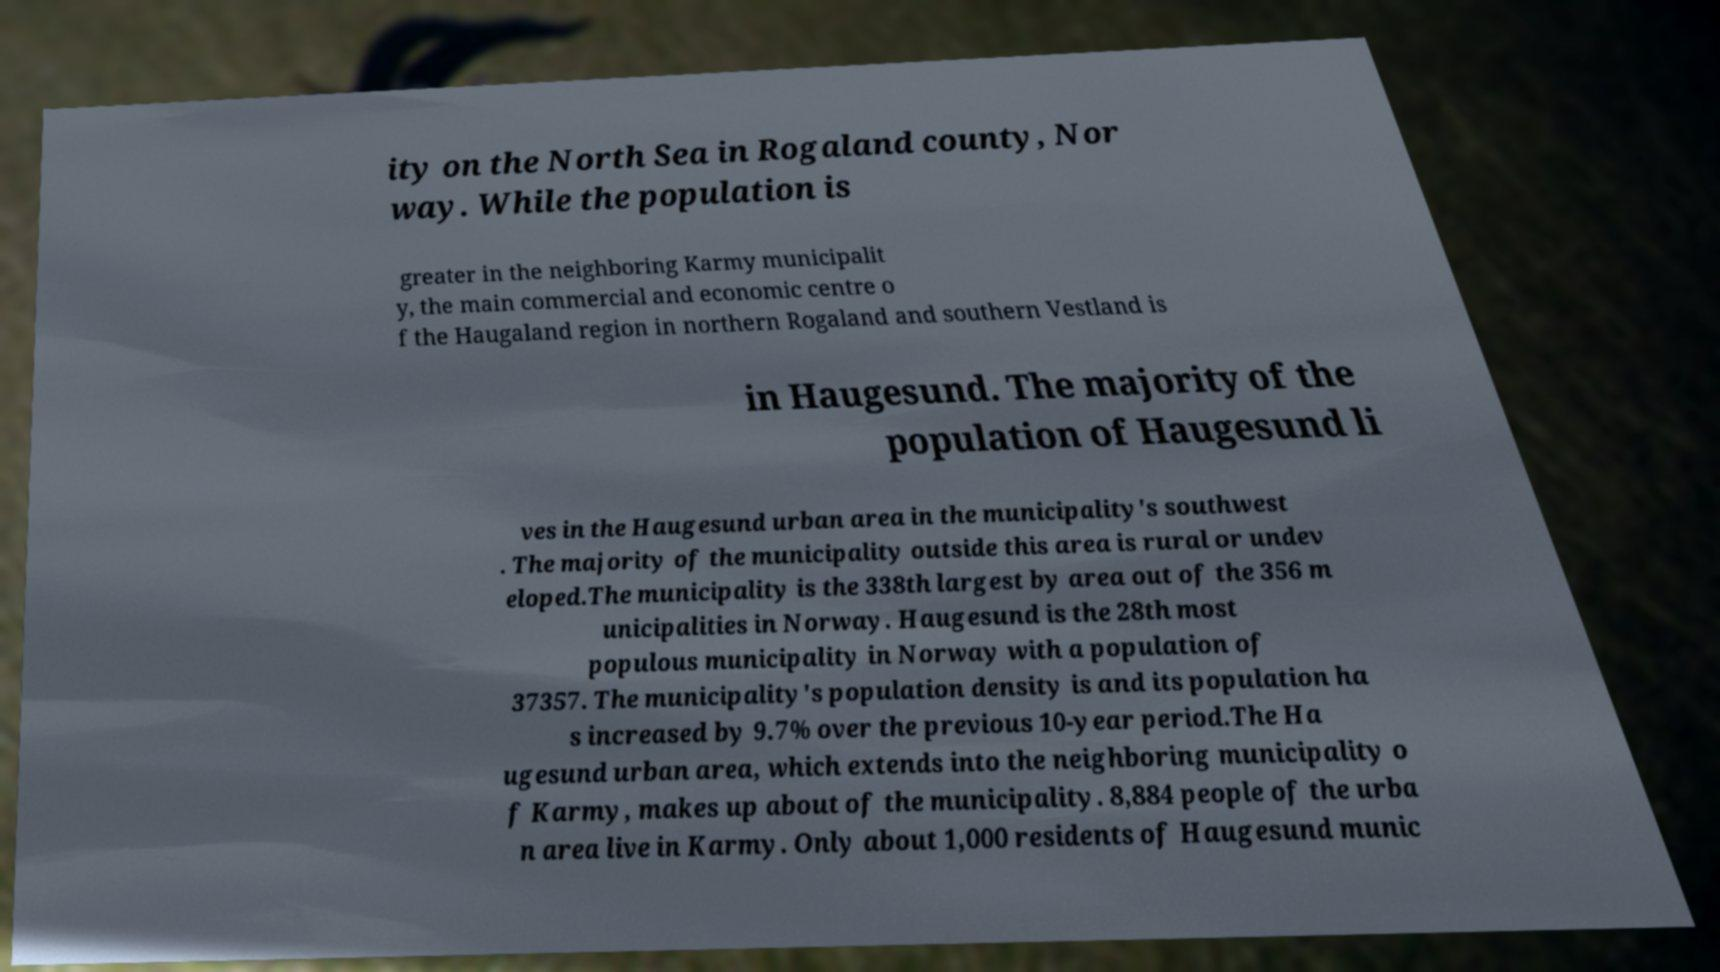There's text embedded in this image that I need extracted. Can you transcribe it verbatim? ity on the North Sea in Rogaland county, Nor way. While the population is greater in the neighboring Karmy municipalit y, the main commercial and economic centre o f the Haugaland region in northern Rogaland and southern Vestland is in Haugesund. The majority of the population of Haugesund li ves in the Haugesund urban area in the municipality's southwest . The majority of the municipality outside this area is rural or undev eloped.The municipality is the 338th largest by area out of the 356 m unicipalities in Norway. Haugesund is the 28th most populous municipality in Norway with a population of 37357. The municipality's population density is and its population ha s increased by 9.7% over the previous 10-year period.The Ha ugesund urban area, which extends into the neighboring municipality o f Karmy, makes up about of the municipality. 8,884 people of the urba n area live in Karmy. Only about 1,000 residents of Haugesund munic 